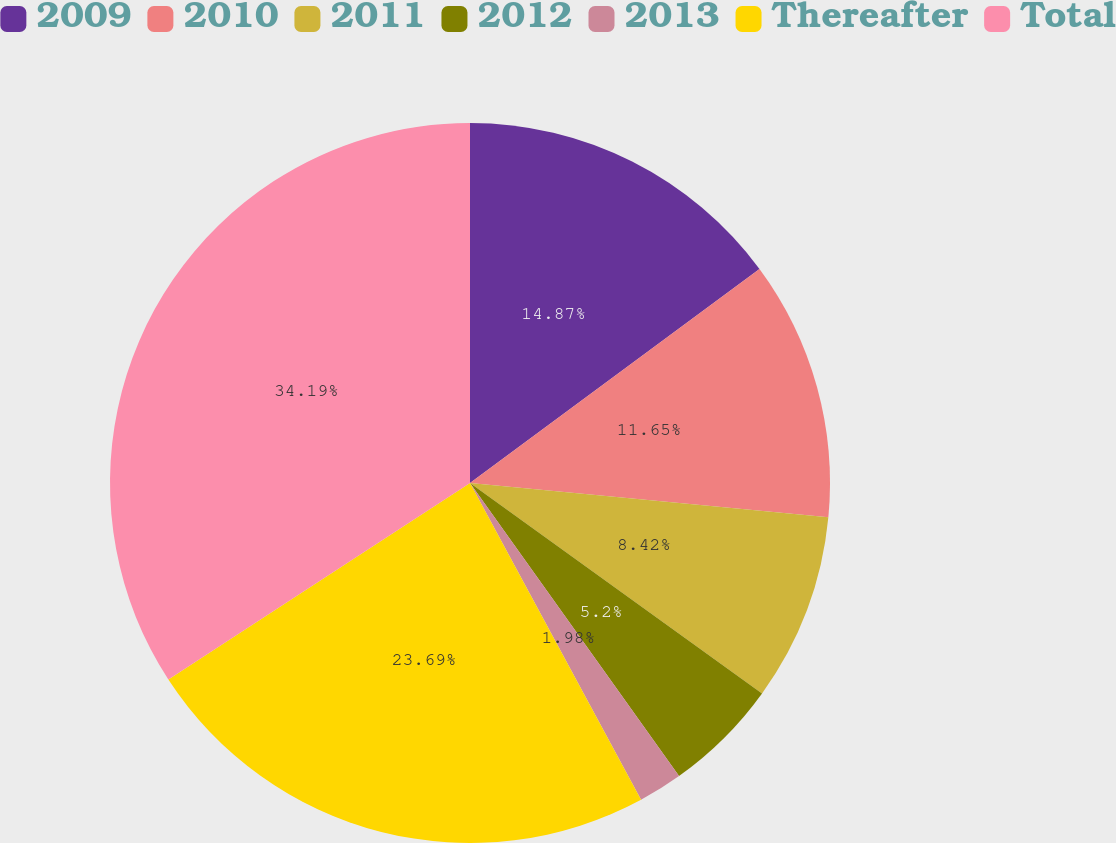<chart> <loc_0><loc_0><loc_500><loc_500><pie_chart><fcel>2009<fcel>2010<fcel>2011<fcel>2012<fcel>2013<fcel>Thereafter<fcel>Total<nl><fcel>14.87%<fcel>11.65%<fcel>8.42%<fcel>5.2%<fcel>1.98%<fcel>23.69%<fcel>34.19%<nl></chart> 